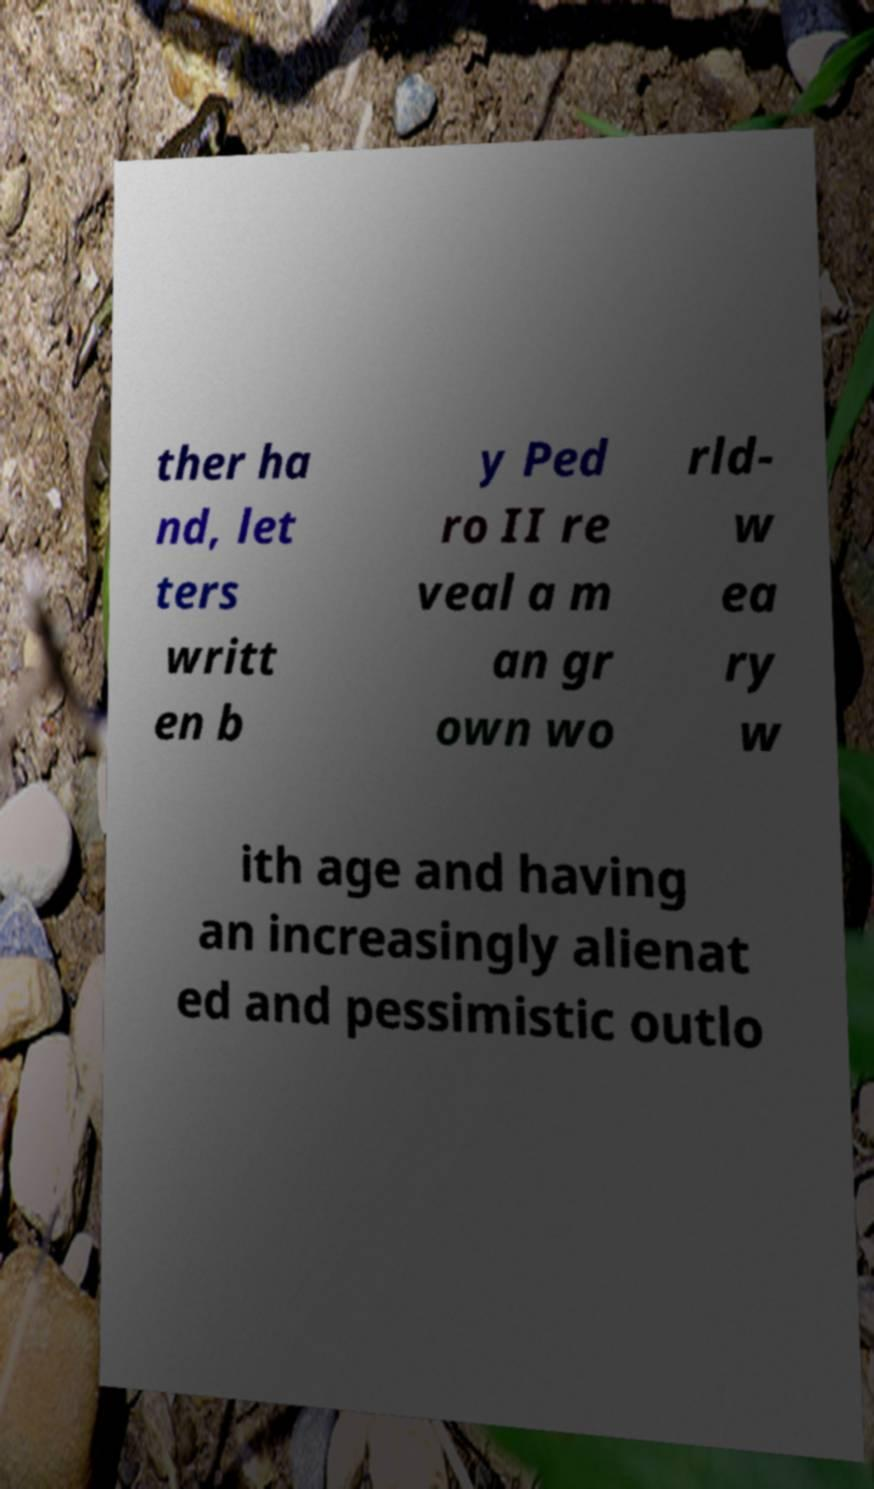I need the written content from this picture converted into text. Can you do that? ther ha nd, let ters writt en b y Ped ro II re veal a m an gr own wo rld- w ea ry w ith age and having an increasingly alienat ed and pessimistic outlo 